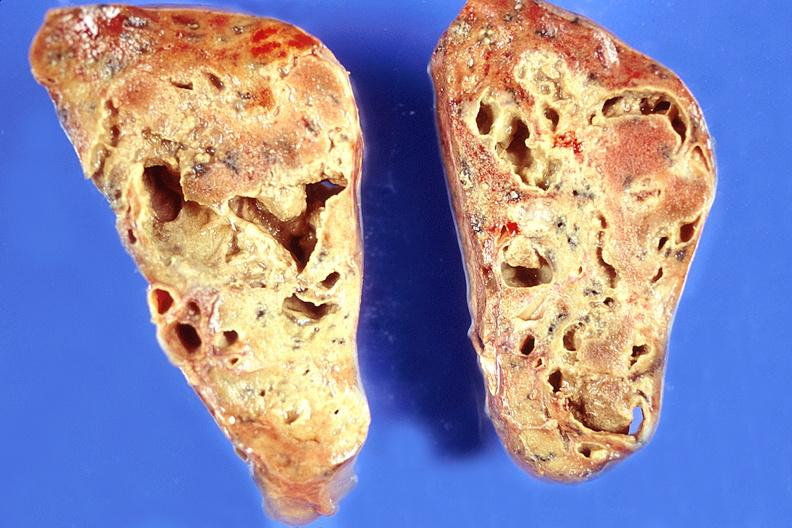s umbilical cord present?
Answer the question using a single word or phrase. No 